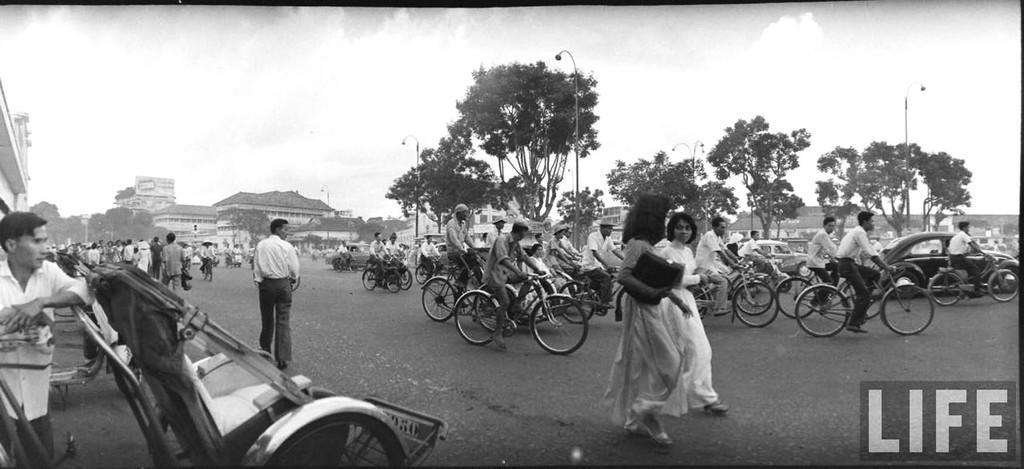In one or two sentences, can you explain what this image depicts? In this picture there are group of people, those who are cycling on the road, there are some trees around the area of the image, it seems to be a road side, there are some cars at the right side of the image, it is a day time and the word life is written at the right bottom corner of the image. 